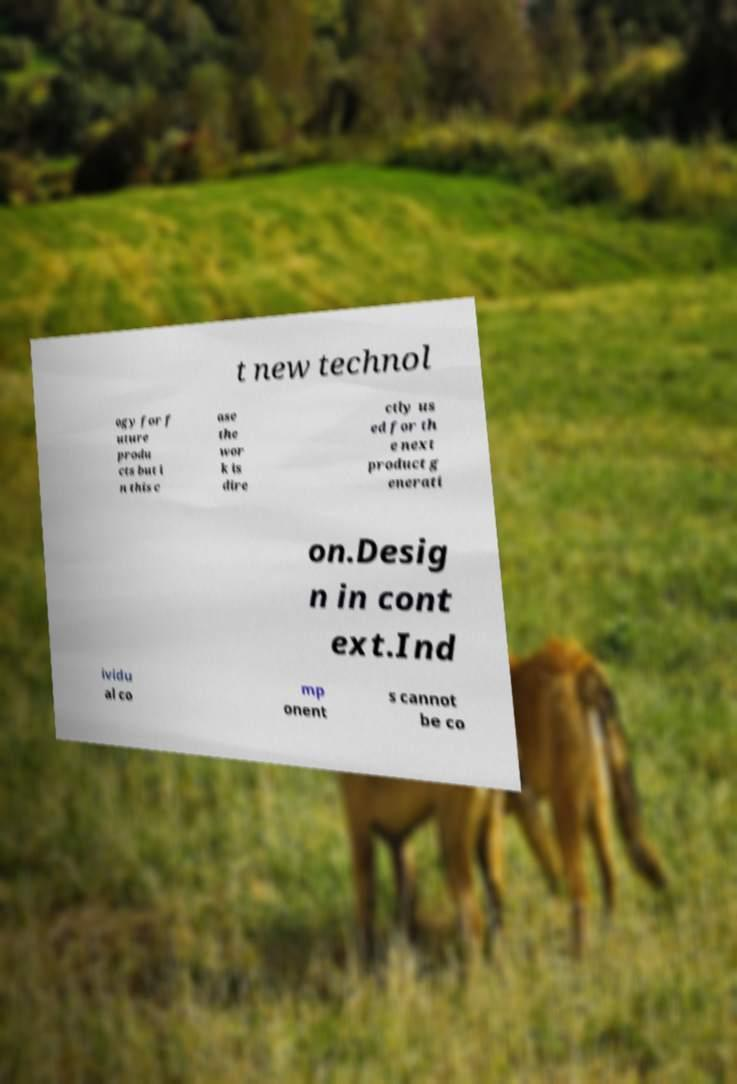What messages or text are displayed in this image? I need them in a readable, typed format. t new technol ogy for f uture produ cts but i n this c ase the wor k is dire ctly us ed for th e next product g enerati on.Desig n in cont ext.Ind ividu al co mp onent s cannot be co 